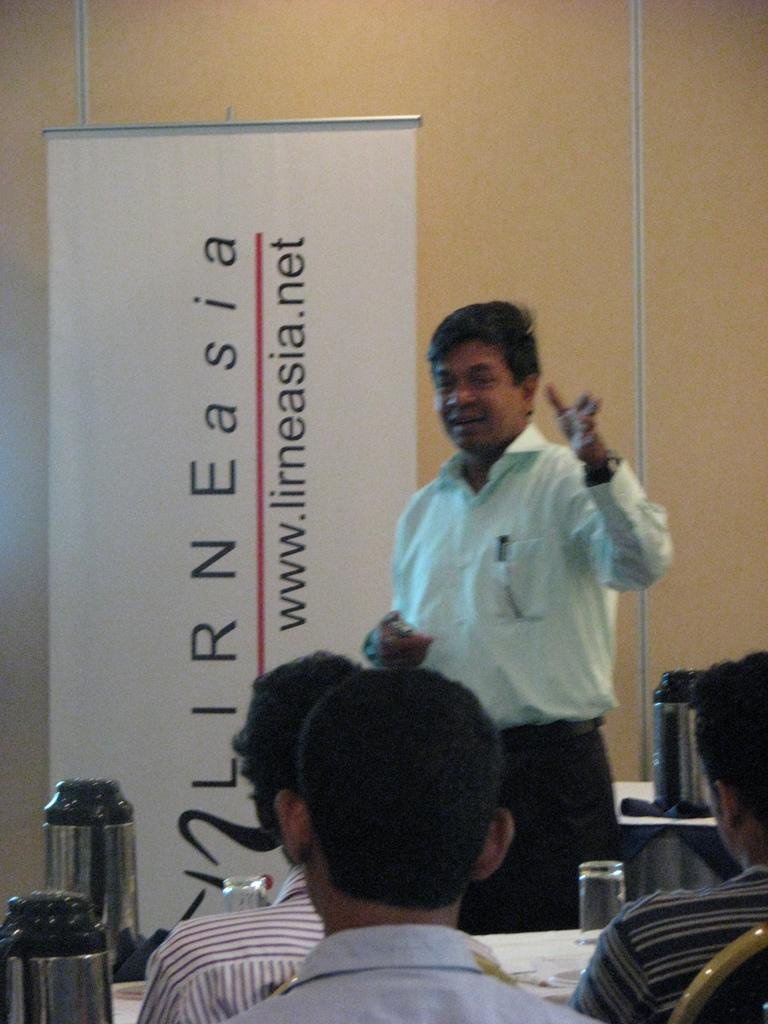<image>
Offer a succinct explanation of the picture presented. Professor teaching a class sponsored by the website lirneasia.net. 